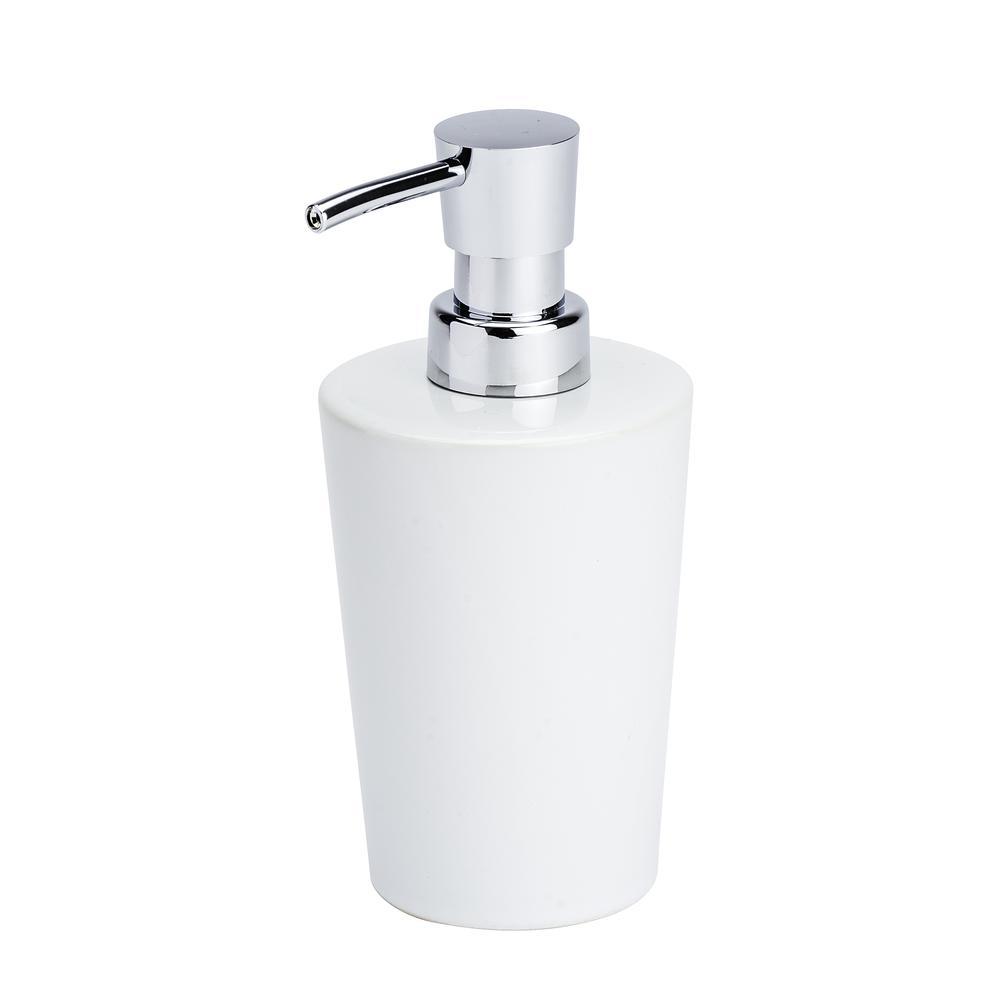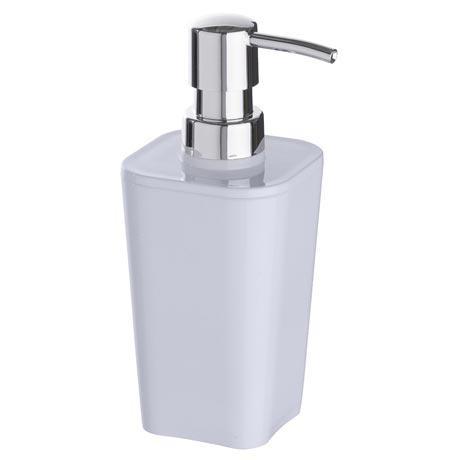The first image is the image on the left, the second image is the image on the right. Given the left and right images, does the statement "There is one round soap dispenser with the spout pointing to the left." hold true? Answer yes or no. Yes. The first image is the image on the left, the second image is the image on the right. Analyze the images presented: Is the assertion "There is a silver dispenser with three nozzles in the right image." valid? Answer yes or no. No. 